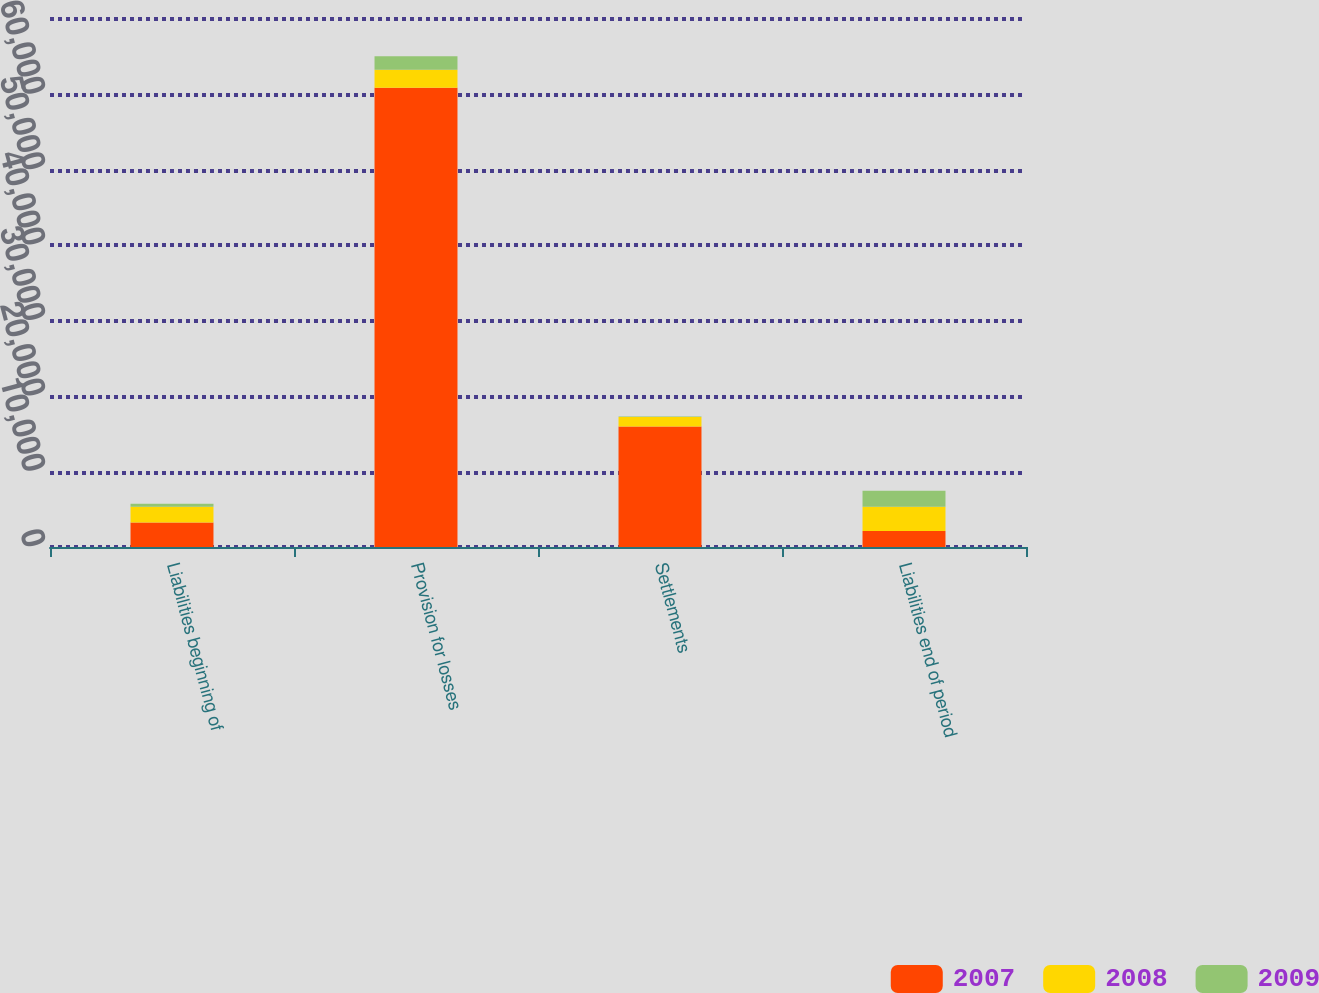Convert chart. <chart><loc_0><loc_0><loc_500><loc_500><stacked_bar_chart><ecel><fcel>Liabilities beginning of<fcel>Provision for losses<fcel>Settlements<fcel>Liabilities end of period<nl><fcel>2007<fcel>3240<fcel>60896<fcel>15983<fcel>2107<nl><fcel>2008<fcel>2107<fcel>2370<fcel>1237<fcel>3240<nl><fcel>2009<fcel>395<fcel>1787<fcel>75<fcel>2107<nl></chart> 